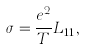<formula> <loc_0><loc_0><loc_500><loc_500>\sigma = \frac { e ^ { 2 } } { T } L _ { 1 1 } ,</formula> 